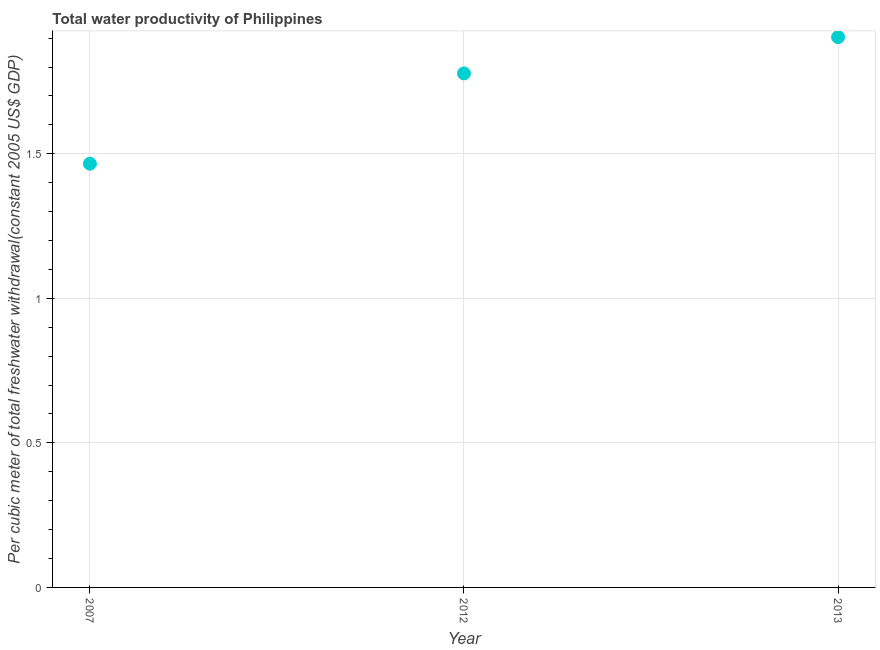What is the total water productivity in 2007?
Your answer should be very brief. 1.47. Across all years, what is the maximum total water productivity?
Give a very brief answer. 1.9. Across all years, what is the minimum total water productivity?
Provide a short and direct response. 1.47. In which year was the total water productivity minimum?
Ensure brevity in your answer.  2007. What is the sum of the total water productivity?
Provide a succinct answer. 5.15. What is the difference between the total water productivity in 2012 and 2013?
Make the answer very short. -0.13. What is the average total water productivity per year?
Your answer should be compact. 1.72. What is the median total water productivity?
Keep it short and to the point. 1.78. In how many years, is the total water productivity greater than 0.4 US$?
Keep it short and to the point. 3. Do a majority of the years between 2013 and 2012 (inclusive) have total water productivity greater than 1.8 US$?
Offer a terse response. No. What is the ratio of the total water productivity in 2007 to that in 2013?
Make the answer very short. 0.77. What is the difference between the highest and the second highest total water productivity?
Make the answer very short. 0.13. What is the difference between the highest and the lowest total water productivity?
Provide a short and direct response. 0.44. Does the total water productivity monotonically increase over the years?
Make the answer very short. Yes. How many dotlines are there?
Your response must be concise. 1. Are the values on the major ticks of Y-axis written in scientific E-notation?
Make the answer very short. No. Does the graph contain any zero values?
Offer a very short reply. No. Does the graph contain grids?
Your answer should be compact. Yes. What is the title of the graph?
Provide a short and direct response. Total water productivity of Philippines. What is the label or title of the Y-axis?
Make the answer very short. Per cubic meter of total freshwater withdrawal(constant 2005 US$ GDP). What is the Per cubic meter of total freshwater withdrawal(constant 2005 US$ GDP) in 2007?
Offer a very short reply. 1.47. What is the Per cubic meter of total freshwater withdrawal(constant 2005 US$ GDP) in 2012?
Offer a very short reply. 1.78. What is the Per cubic meter of total freshwater withdrawal(constant 2005 US$ GDP) in 2013?
Offer a terse response. 1.9. What is the difference between the Per cubic meter of total freshwater withdrawal(constant 2005 US$ GDP) in 2007 and 2012?
Provide a short and direct response. -0.31. What is the difference between the Per cubic meter of total freshwater withdrawal(constant 2005 US$ GDP) in 2007 and 2013?
Make the answer very short. -0.44. What is the difference between the Per cubic meter of total freshwater withdrawal(constant 2005 US$ GDP) in 2012 and 2013?
Offer a very short reply. -0.13. What is the ratio of the Per cubic meter of total freshwater withdrawal(constant 2005 US$ GDP) in 2007 to that in 2012?
Your answer should be compact. 0.82. What is the ratio of the Per cubic meter of total freshwater withdrawal(constant 2005 US$ GDP) in 2007 to that in 2013?
Keep it short and to the point. 0.77. What is the ratio of the Per cubic meter of total freshwater withdrawal(constant 2005 US$ GDP) in 2012 to that in 2013?
Provide a short and direct response. 0.93. 